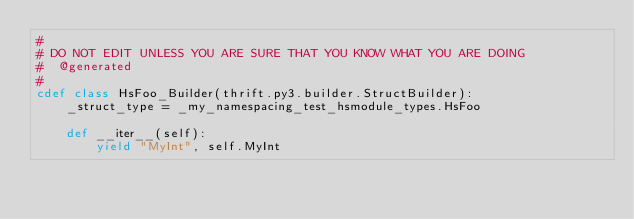<code> <loc_0><loc_0><loc_500><loc_500><_Cython_>#
# DO NOT EDIT UNLESS YOU ARE SURE THAT YOU KNOW WHAT YOU ARE DOING
#  @generated
#
cdef class HsFoo_Builder(thrift.py3.builder.StructBuilder):
    _struct_type = _my_namespacing_test_hsmodule_types.HsFoo

    def __iter__(self):
        yield "MyInt", self.MyInt

</code> 